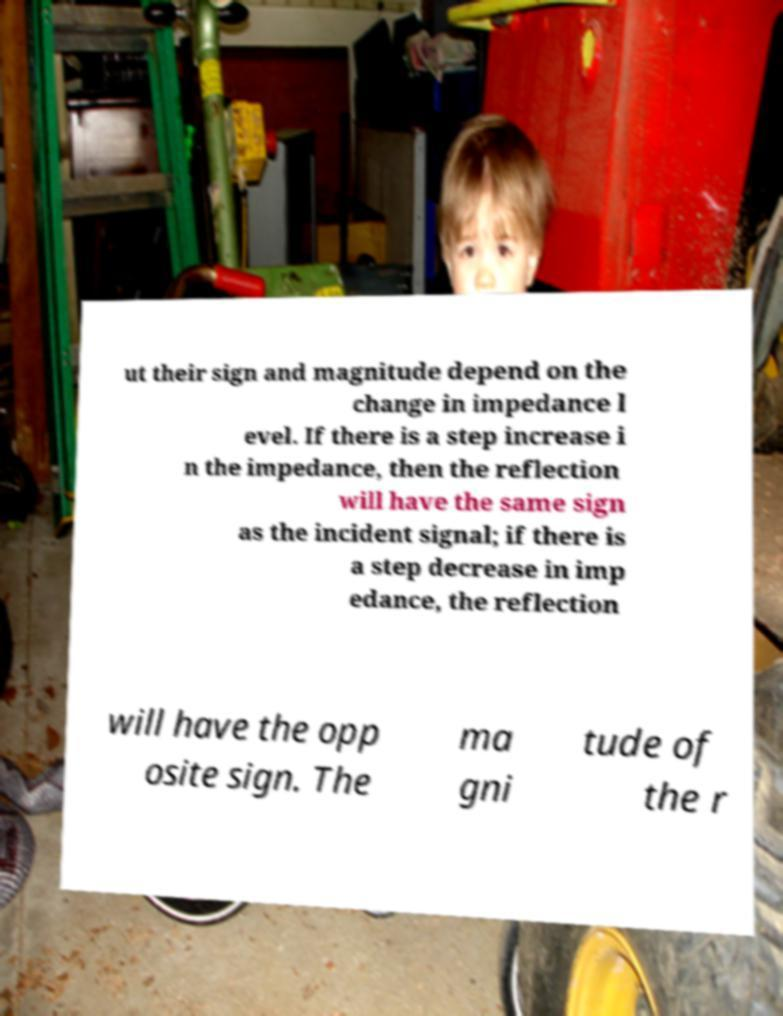For documentation purposes, I need the text within this image transcribed. Could you provide that? ut their sign and magnitude depend on the change in impedance l evel. If there is a step increase i n the impedance, then the reflection will have the same sign as the incident signal; if there is a step decrease in imp edance, the reflection will have the opp osite sign. The ma gni tude of the r 